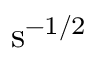<formula> <loc_0><loc_0><loc_500><loc_500>s ^ { - 1 / 2 }</formula> 